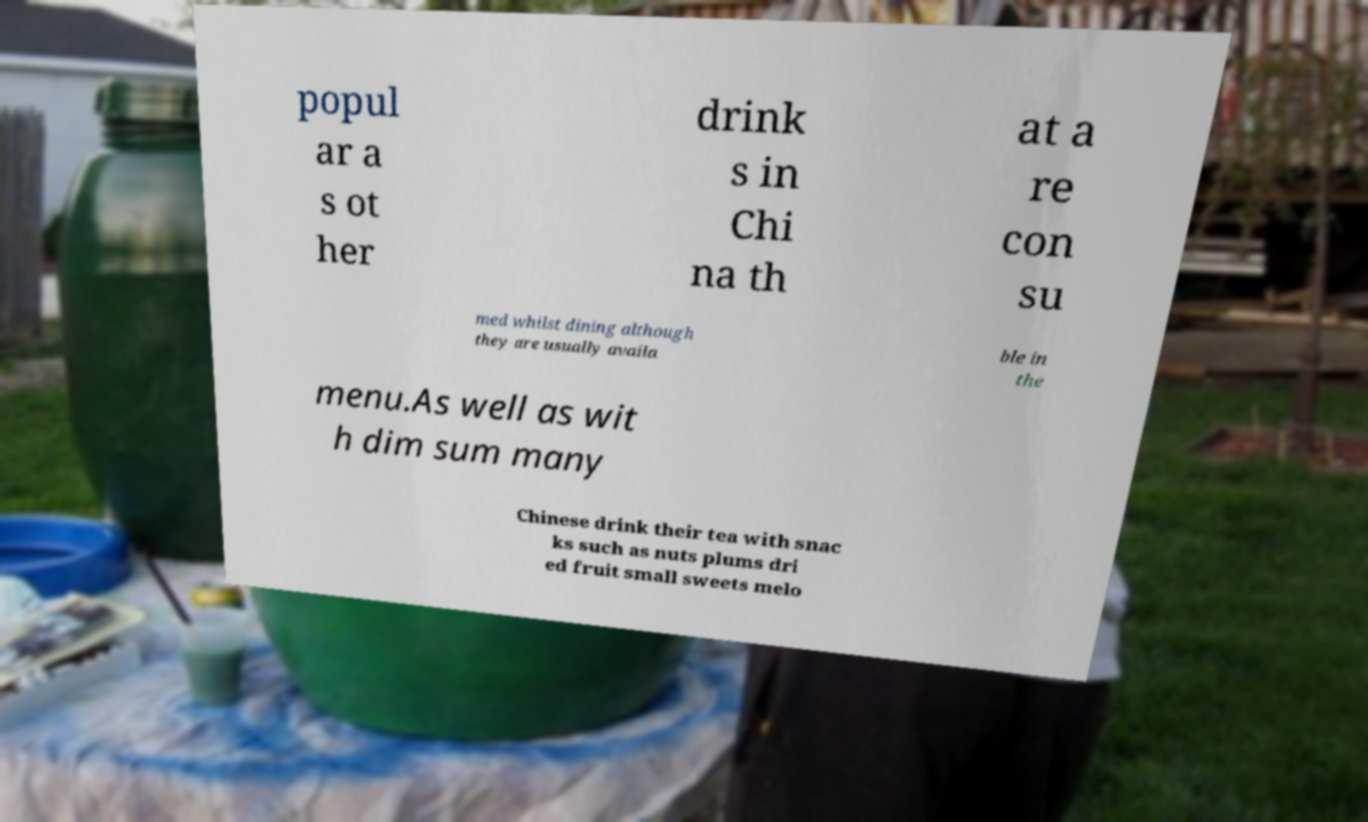There's text embedded in this image that I need extracted. Can you transcribe it verbatim? popul ar a s ot her drink s in Chi na th at a re con su med whilst dining although they are usually availa ble in the menu.As well as wit h dim sum many Chinese drink their tea with snac ks such as nuts plums dri ed fruit small sweets melo 